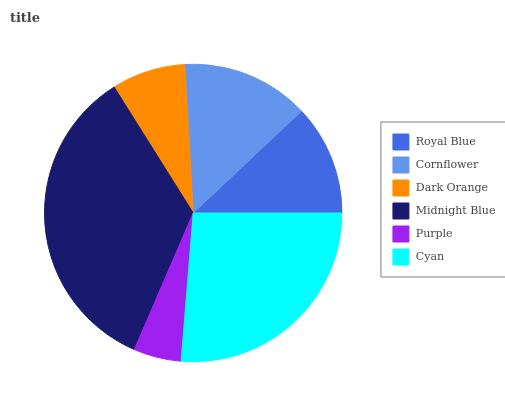Is Purple the minimum?
Answer yes or no. Yes. Is Midnight Blue the maximum?
Answer yes or no. Yes. Is Cornflower the minimum?
Answer yes or no. No. Is Cornflower the maximum?
Answer yes or no. No. Is Cornflower greater than Royal Blue?
Answer yes or no. Yes. Is Royal Blue less than Cornflower?
Answer yes or no. Yes. Is Royal Blue greater than Cornflower?
Answer yes or no. No. Is Cornflower less than Royal Blue?
Answer yes or no. No. Is Cornflower the high median?
Answer yes or no. Yes. Is Royal Blue the low median?
Answer yes or no. Yes. Is Purple the high median?
Answer yes or no. No. Is Dark Orange the low median?
Answer yes or no. No. 